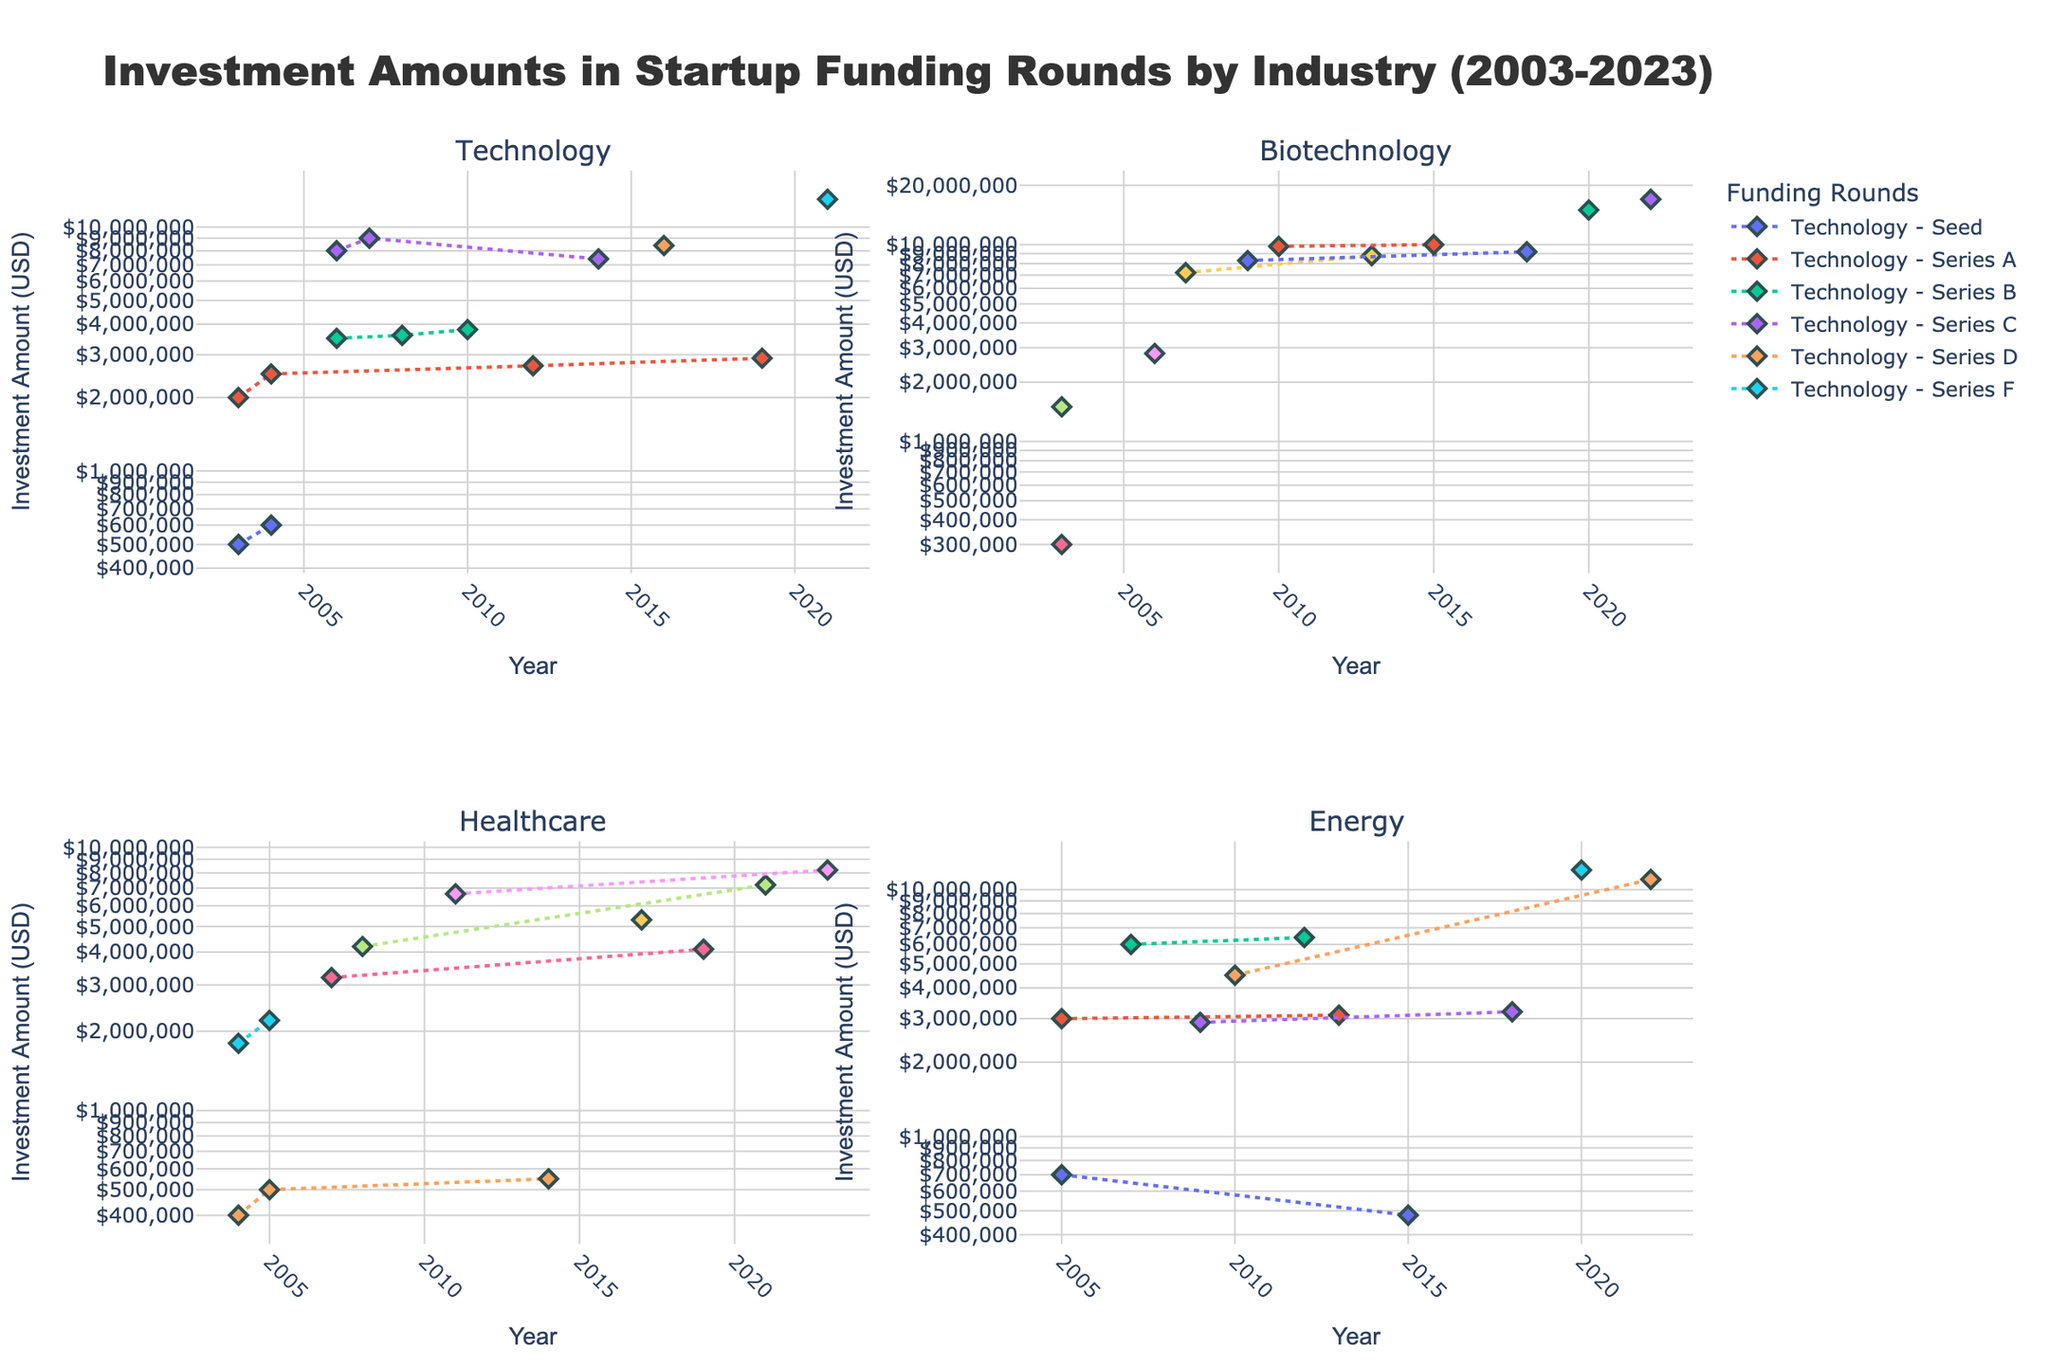How many years are displayed in the figure? The x-axis shows the years ranging from 2003 to 2023, and we can count these years to find the total number of years displayed.
Answer: 21 What is the title of the figure? The title is typically placed at the top of the figure for easy identification, which in this case can be read directly.
Answer: Investment Amounts in Startup Funding Rounds by Industry (2003-2023) In which year did the Technology sector receive its first Series B funding? By examining the data points for the Technology sector subplot, we identify the year of the first Series B funding. It shows in 2006.
Answer: 2006 Which industry had the highest investment amount in any single funding round and what was that amount? By comparing the highest data points across all subplots, we find that Biotechnology had the highest investment amount with $17,000,000 in Series G funding in 2022.
Answer: Biotechnology, $17,000,000 How does the investment amount in Series A for the Technology sector in 2012 compare to that in 2003? By locating these two data points in the Technology sector subplot, we see that the Series A funding in 2012 was $2,700,000 and in 2003 it was $2,000,000, indicating an increase.
Answer: Increased What's the median value of Series B funding amounts in the Energy sector? The Series B funding amounts for Energy are $2,900,000 (2009) and $3,200,000 (2018). The median is the average of these two values because there are only two data points: ($2,900,000 + $3,200,000) / 2 = $3,050,000.
Answer: $3,050,000 Which sector shows the most consistent growth in investment amounts across the years? By analyzing the trend lines within each subplot, we observe that the Technology sector shows a relatively consistent upward trend in its investment amounts across different funding rounds over the years.
Answer: Technology Which funding round has the highest variability in investment amounts within each sector and what does this indicate? By inspecting the spread of data points within each sector's subplot for each funding round, Series E in Biotechnology shows the highest variability, indicating significant fluctuations in the investment amounts.
Answer: Series E, Biotechnology Does the logarithmic y-axis affect how we perceive the differences in investment amounts? The logarithmic scale compresses the range of data, making differences in higher amounts less pronounced visually compared to a linear scale. This scaling helps in better visualizing a wide range of investment amounts.
Answer: Yes 